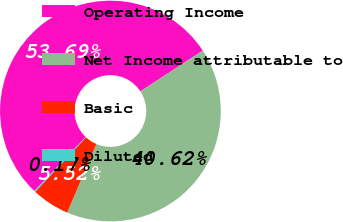<chart> <loc_0><loc_0><loc_500><loc_500><pie_chart><fcel>Operating Income<fcel>Net Income attributable to<fcel>Basic<fcel>Diluted<nl><fcel>53.69%<fcel>40.62%<fcel>5.52%<fcel>0.17%<nl></chart> 